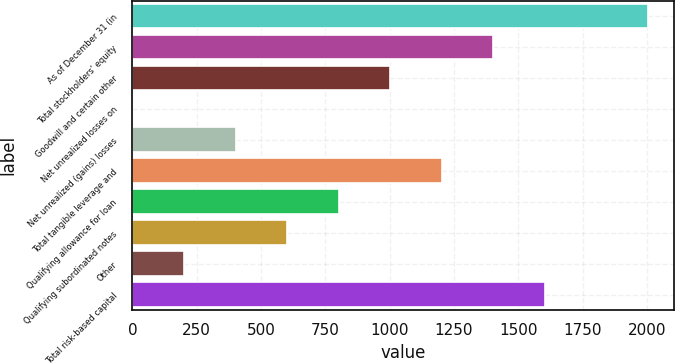Convert chart. <chart><loc_0><loc_0><loc_500><loc_500><bar_chart><fcel>As of December 31 (in<fcel>Total stockholders' equity<fcel>Goodwill and certain other<fcel>Net unrealized losses on<fcel>Net unrealized (gains) losses<fcel>Total tangible leverage and<fcel>Qualifying allowance for loan<fcel>Qualifying subordinated notes<fcel>Other<fcel>Total risk-based capital<nl><fcel>2005<fcel>1403.53<fcel>1002.55<fcel>0.1<fcel>401.08<fcel>1203.04<fcel>802.06<fcel>601.57<fcel>200.59<fcel>1604.02<nl></chart> 